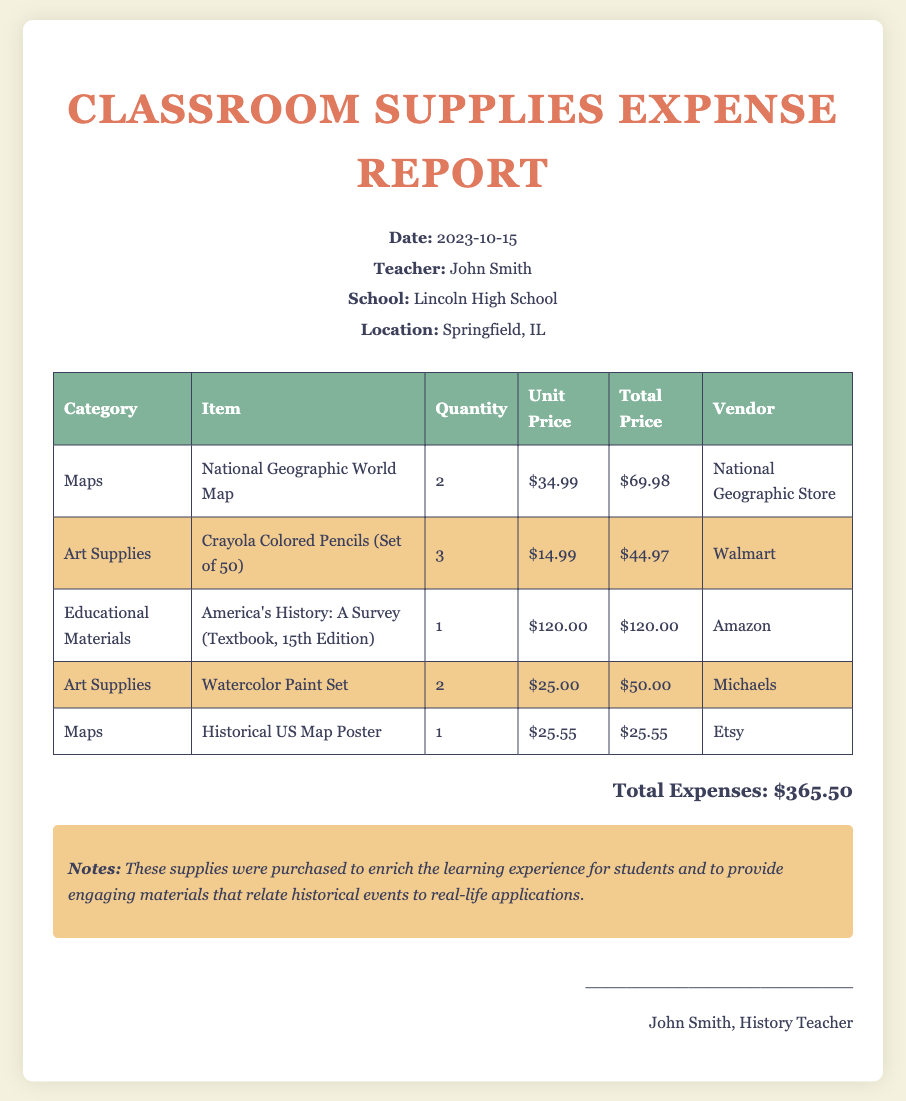What is the date of the report? The date of the report is stated in the header section, which is 2023-10-15.
Answer: 2023-10-15 Who is the teacher mentioned in the report? The teacher's name is provided in the document's header, identified as John Smith.
Answer: John Smith What is the total amount spent on supplies? The total amount reflects the sum of all expenses listed at the bottom of the document, which is $365.50.
Answer: $365.50 How many National Geographic World Maps were purchased? The quantity of National Geographic World Maps is specified in the item entry, which shows 2 were bought.
Answer: 2 Which vendor supplied the Crayola Colored Pencils? The vendor is noted in the inventory table next to the Crayola Colored Pencils, which is Walmart.
Answer: Walmart Why were these supplies purchased? The reason for the purchases is elaborated in the notes section, emphasizing enrichment of the learning experience.
Answer: To enrich the learning experience What is the unit price of the Watercolor Paint Set? The unit price can be found in the corresponding entry in the table, which is $25.00.
Answer: $25.00 How many items are listed under the category 'Maps'? By counting the entries in the table, there are 2 items listed under the 'Maps' category.
Answer: 2 What is the title of the textbook listed in the report? The title for the textbook is found in the educational materials entry, which is America's History: A Survey (Textbook, 15th Edition).
Answer: America's History: A Survey (Textbook, 15th Edition) 